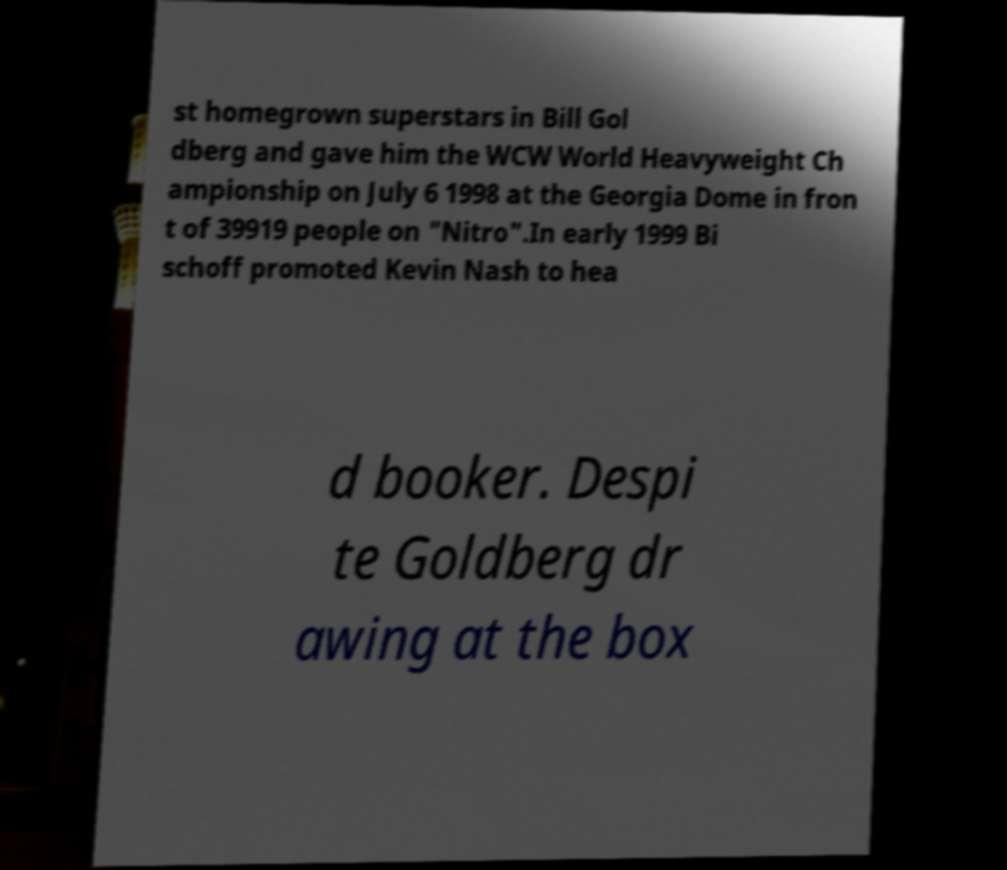Please identify and transcribe the text found in this image. st homegrown superstars in Bill Gol dberg and gave him the WCW World Heavyweight Ch ampionship on July 6 1998 at the Georgia Dome in fron t of 39919 people on "Nitro".In early 1999 Bi schoff promoted Kevin Nash to hea d booker. Despi te Goldberg dr awing at the box 